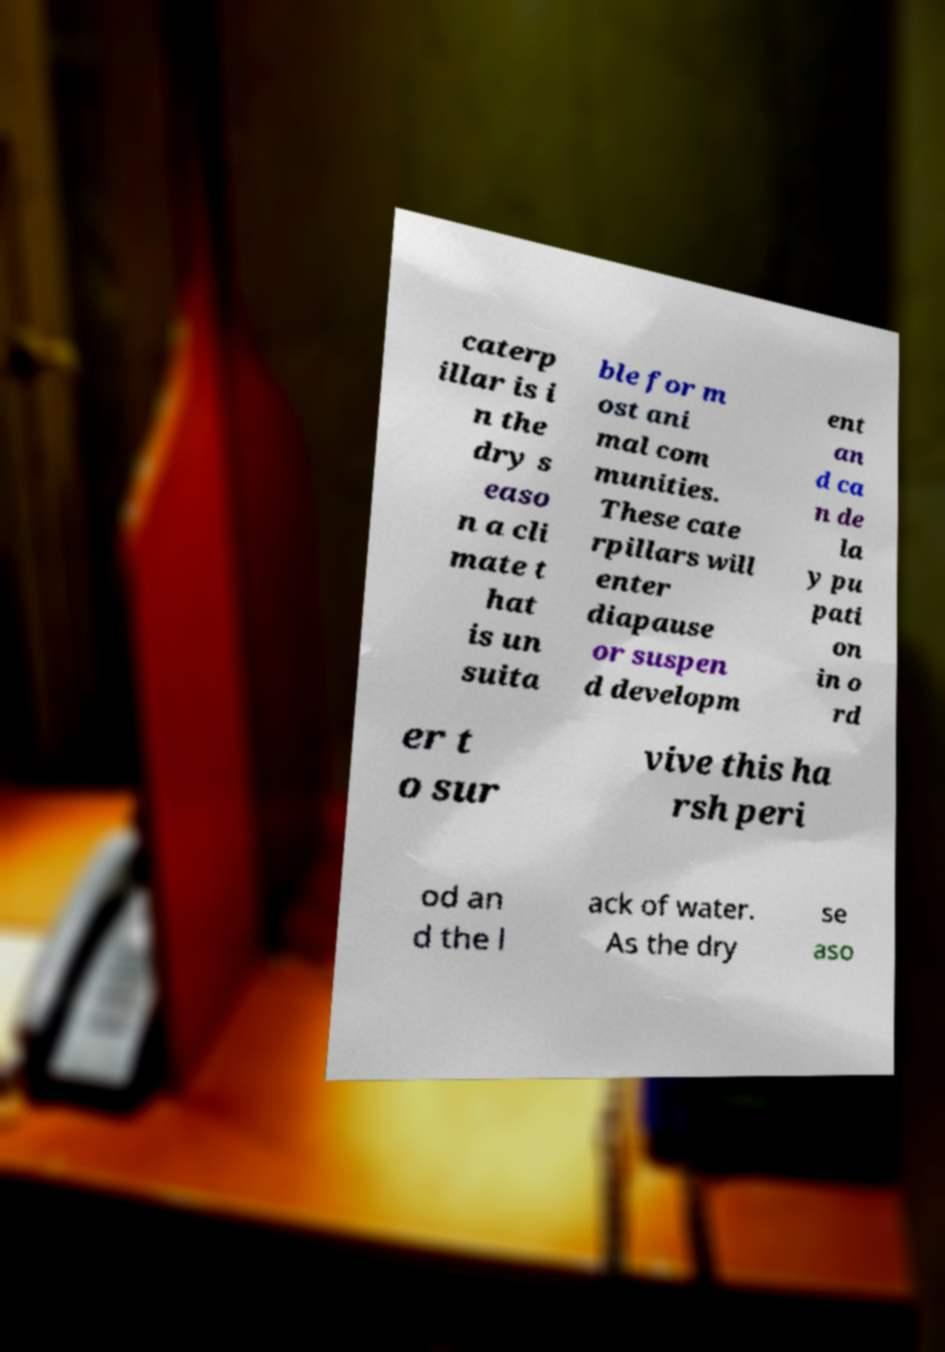Please identify and transcribe the text found in this image. caterp illar is i n the dry s easo n a cli mate t hat is un suita ble for m ost ani mal com munities. These cate rpillars will enter diapause or suspen d developm ent an d ca n de la y pu pati on in o rd er t o sur vive this ha rsh peri od an d the l ack of water. As the dry se aso 